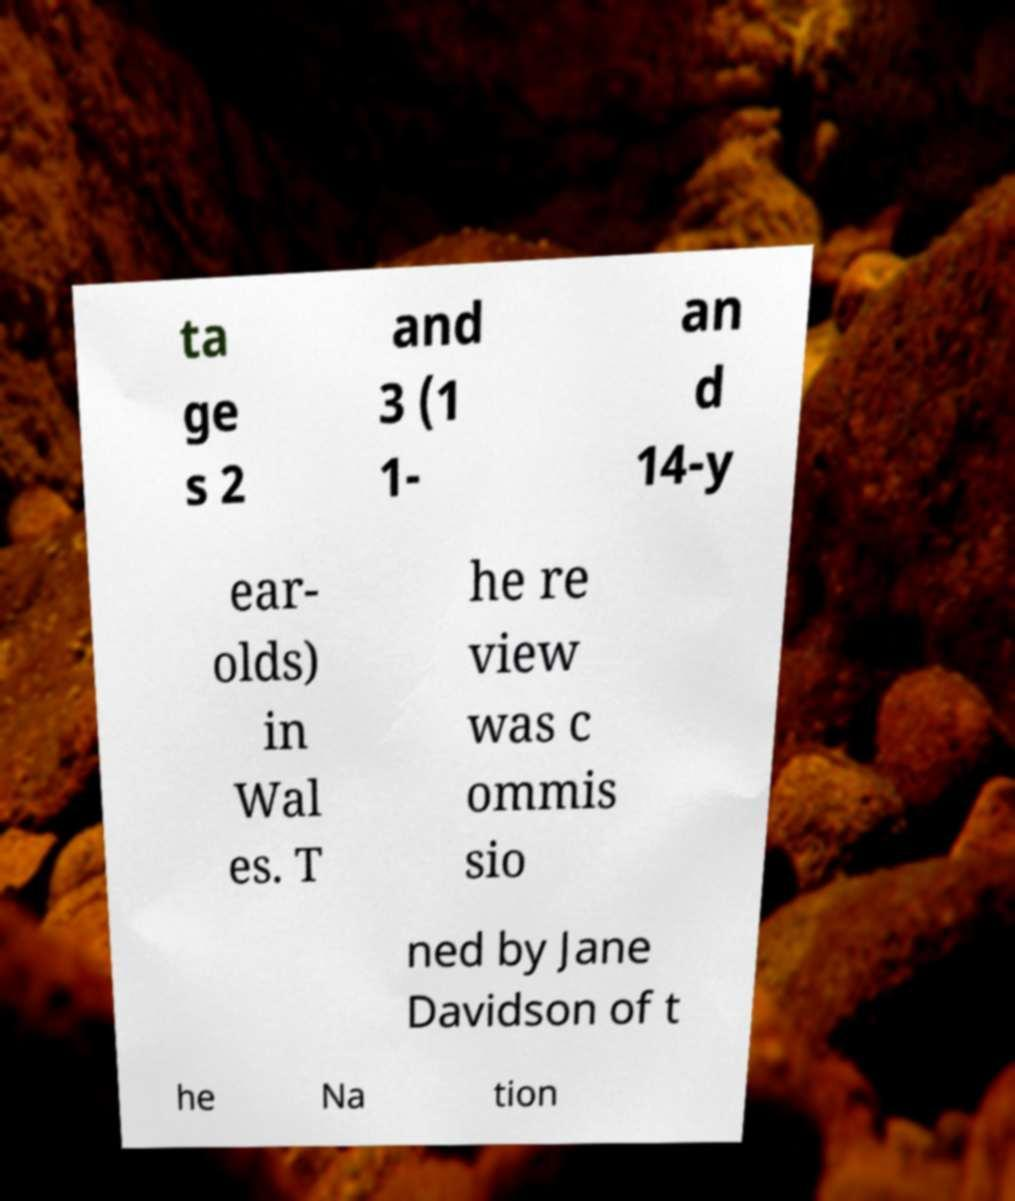Please identify and transcribe the text found in this image. ta ge s 2 and 3 (1 1- an d 14-y ear- olds) in Wal es. T he re view was c ommis sio ned by Jane Davidson of t he Na tion 